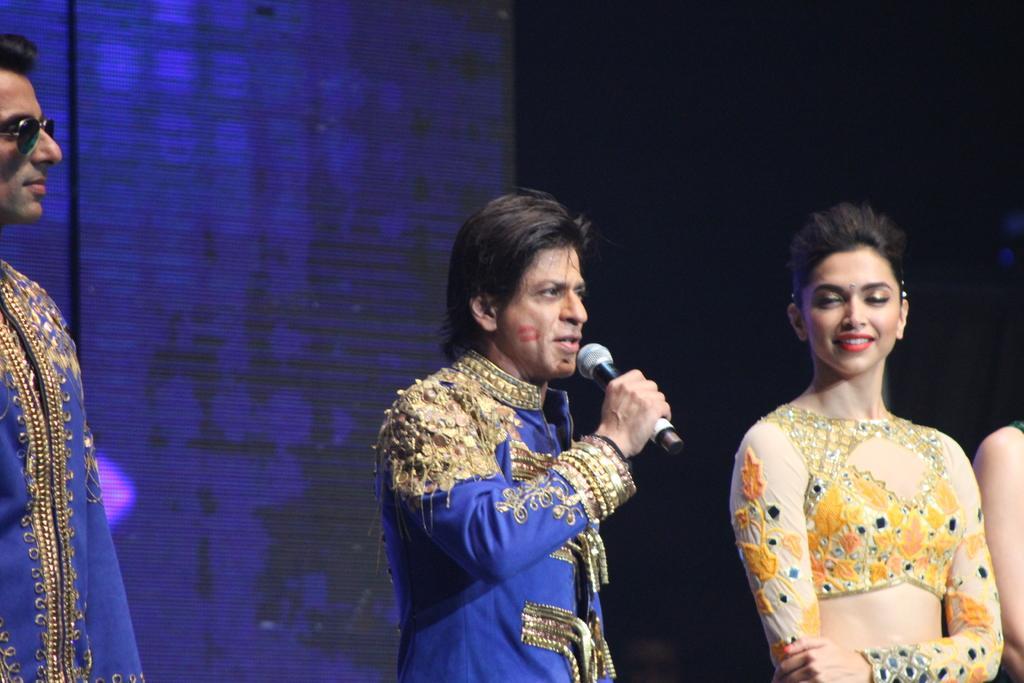Describe this image in one or two sentences. In this picture we can see a man holding a mic with his hand and beside him we can see two people and in the background we can see an object and it is dark. 